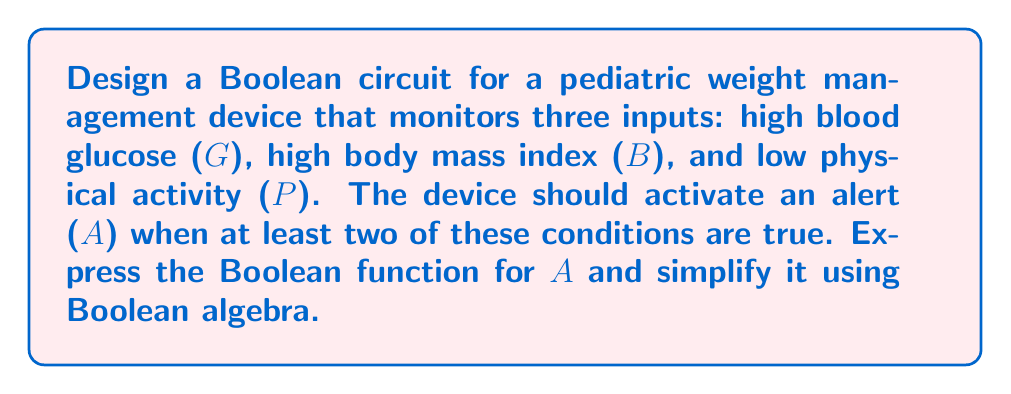Solve this math problem. Let's approach this step-by-step:

1) First, we need to express the Boolean function for A. The alert should activate when at least two of the three conditions are true. This can be represented as:

   $$A = GB + GP + BP$$

2) To simplify this expression, we can use the distributive law and absorption law of Boolean algebra:

   $$A = GB + GP + BP$$
   $$A = G(B + P) + BP$$

3) Using the absorption law, we can simplify further:

   $$A = G(B + P) + BP$$
   $$A = GB + GP + BP$$

4) We've arrived back at our original expression, which means this is already in its simplest form.

5) To implement this as a circuit, we need:
   - Three AND gates (for GB, GP, and BP)
   - One OR gate to combine the outputs of the AND gates

[asy]
unitsize(1cm);

pair A1=(0,2), A2=(0,1), A3=(0,0);
pair B1=(2,2), B2=(2,1), B3=(2,0);
pair C=(4,1);
pair D=(6,1);

draw(A1--B1--C--D);
draw(A2--B2--C);
draw(A3--B3--C);

label("G", A1, W);
label("B", A2, W);
label("P", A3, W);

label("AND", (1,2), N);
label("AND", (1,1), N);
label("AND", (1,0), N);

label("OR", (3,1), N);

label("A", D, E);
[/asy]

This circuit implements the Boolean function $$A = GB + GP + BP$$, which will activate the alert when at least two of the three monitored conditions are true.
Answer: $$A = GB + GP + BP$$ 